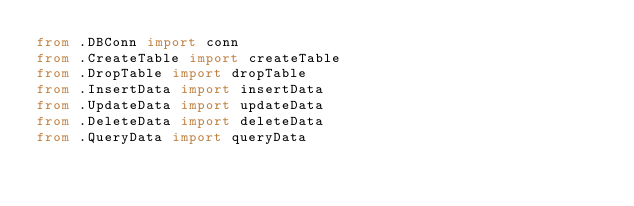<code> <loc_0><loc_0><loc_500><loc_500><_Python_>from .DBConn import conn
from .CreateTable import createTable
from .DropTable import dropTable
from .InsertData import insertData
from .UpdateData import updateData
from .DeleteData import deleteData
from .QueryData import queryData</code> 